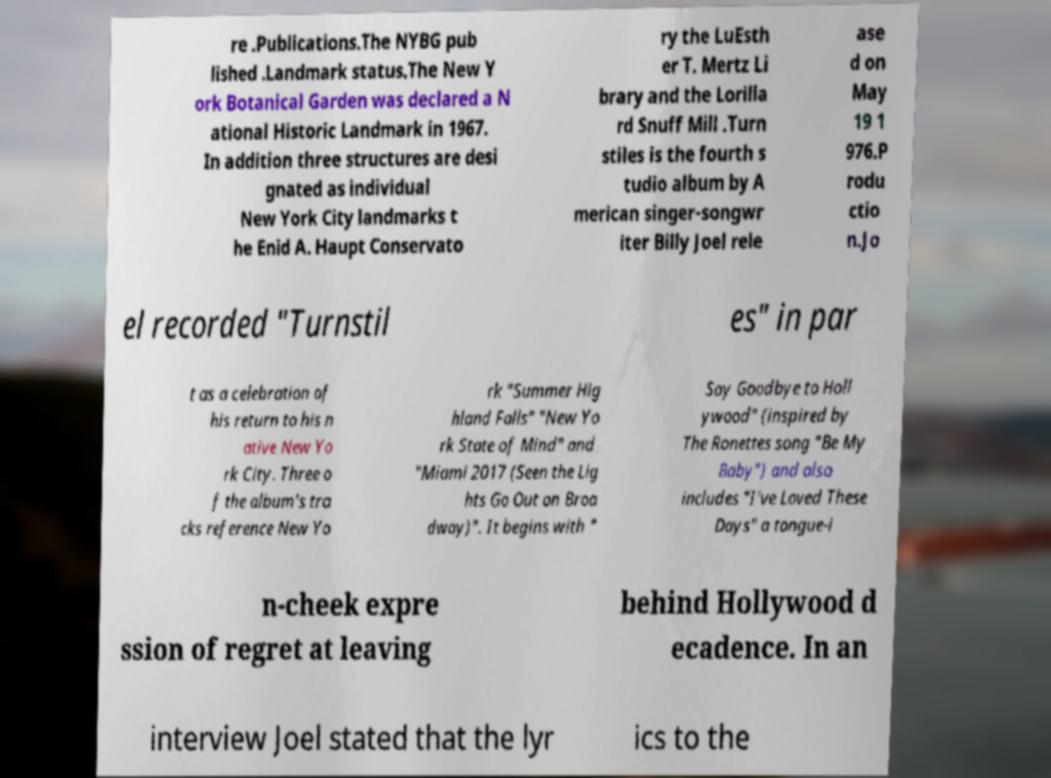Please identify and transcribe the text found in this image. re .Publications.The NYBG pub lished .Landmark status.The New Y ork Botanical Garden was declared a N ational Historic Landmark in 1967. In addition three structures are desi gnated as individual New York City landmarks t he Enid A. Haupt Conservato ry the LuEsth er T. Mertz Li brary and the Lorilla rd Snuff Mill .Turn stiles is the fourth s tudio album by A merican singer-songwr iter Billy Joel rele ase d on May 19 1 976.P rodu ctio n.Jo el recorded "Turnstil es" in par t as a celebration of his return to his n ative New Yo rk City. Three o f the album's tra cks reference New Yo rk "Summer Hig hland Falls" "New Yo rk State of Mind" and "Miami 2017 (Seen the Lig hts Go Out on Broa dway)". It begins with " Say Goodbye to Holl ywood" (inspired by The Ronettes song "Be My Baby") and also includes "I've Loved These Days" a tongue-i n-cheek expre ssion of regret at leaving behind Hollywood d ecadence. In an interview Joel stated that the lyr ics to the 